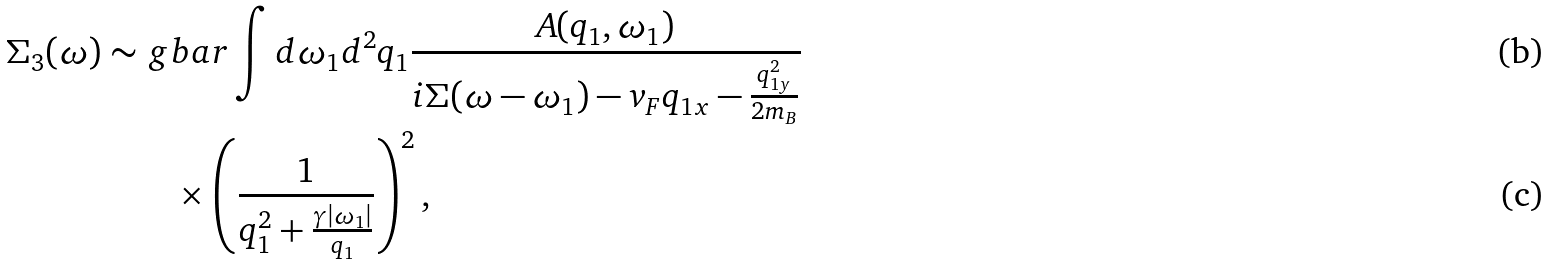<formula> <loc_0><loc_0><loc_500><loc_500>\Sigma _ { 3 } ( \omega ) \sim & \ g b a r \int d \omega _ { 1 } d ^ { 2 } q _ { 1 } \frac { A ( q _ { 1 } , \omega _ { 1 } ) } { i \Sigma ( \omega - \omega _ { 1 } ) - v _ { F } q _ { 1 x } - \frac { q _ { 1 y } ^ { 2 } } { 2 m _ { B } } } \\ & \quad \times \left ( \frac { 1 } { q _ { 1 } ^ { 2 } + \frac { \gamma | \omega _ { 1 } | } { q _ { 1 } } } \right ) ^ { 2 } ,</formula> 